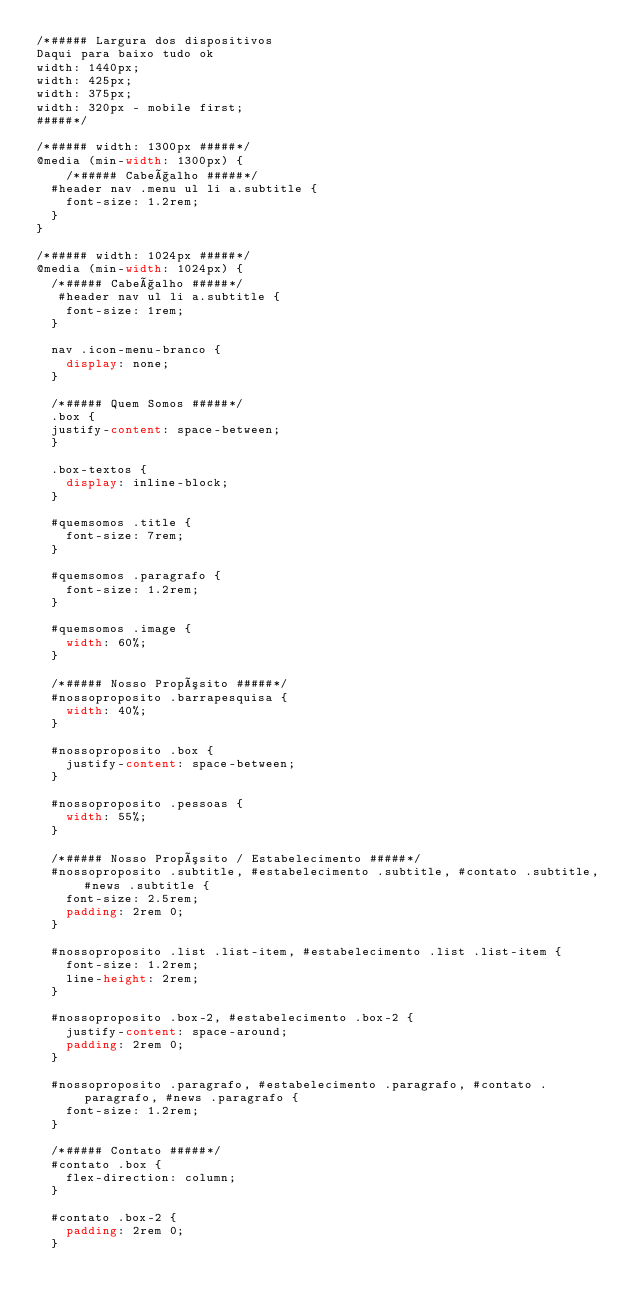Convert code to text. <code><loc_0><loc_0><loc_500><loc_500><_CSS_>/*##### Largura dos dispositivos
Daqui para baixo tudo ok 
width: 1440px; 
width: 425px;
width: 375px;
width: 320px - mobile first; 
#####*/

/*##### width: 1300px #####*/
@media (min-width: 1300px) {
    /*##### Cabeçalho #####*/
  #header nav .menu ul li a.subtitle {
    font-size: 1.2rem;
  }
}

/*##### width: 1024px #####*/
@media (min-width: 1024px) {
  /*##### Cabeçalho #####*/
   #header nav ul li a.subtitle {
    font-size: 1rem;
  }

  nav .icon-menu-branco {
    display: none;
  }

  /*##### Quem Somos #####*/
  .box {
  justify-content: space-between;
  }

  .box-textos {
    display: inline-block;
  }
  
  #quemsomos .title {
    font-size: 7rem;
  }

  #quemsomos .paragrafo {
    font-size: 1.2rem;
  }
  
  #quemsomos .image {
    width: 60%;
  }

  /*##### Nosso Propósito #####*/
  #nossoproposito .barrapesquisa {
    width: 40%;
  }  

  #nossoproposito .box {
    justify-content: space-between;
  }

  #nossoproposito .pessoas {
    width: 55%;
  }

  /*##### Nosso Propósito / Estabelecimento #####*/
  #nossoproposito .subtitle, #estabelecimento .subtitle, #contato .subtitle, #news .subtitle {
    font-size: 2.5rem;
    padding: 2rem 0;
  }

  #nossoproposito .list .list-item, #estabelecimento .list .list-item {
    font-size: 1.2rem;
    line-height: 2rem;
  }  

  #nossoproposito .box-2, #estabelecimento .box-2 {
    justify-content: space-around;
    padding: 2rem 0;
  }

  #nossoproposito .paragrafo, #estabelecimento .paragrafo, #contato .paragrafo, #news .paragrafo {
    font-size: 1.2rem;
  }

  /*##### Contato #####*/
  #contato .box {
    flex-direction: column;
  }

  #contato .box-2 {
    padding: 2rem 0;
  }
</code> 